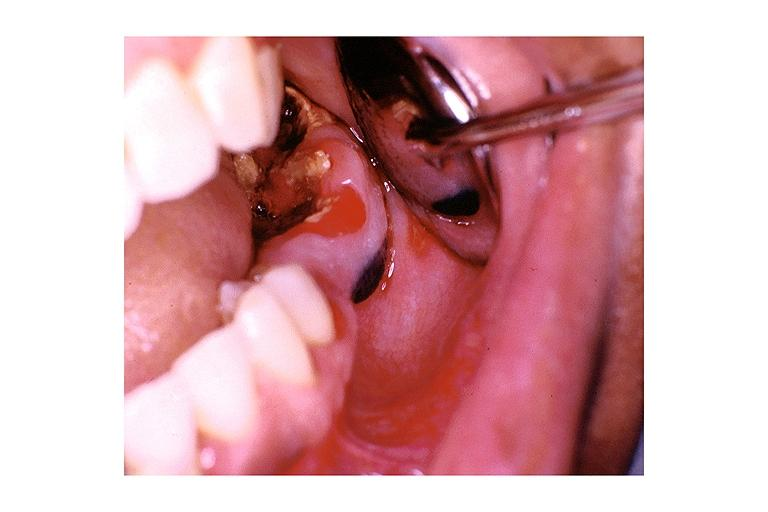what is present?
Answer the question using a single word or phrase. Oral 